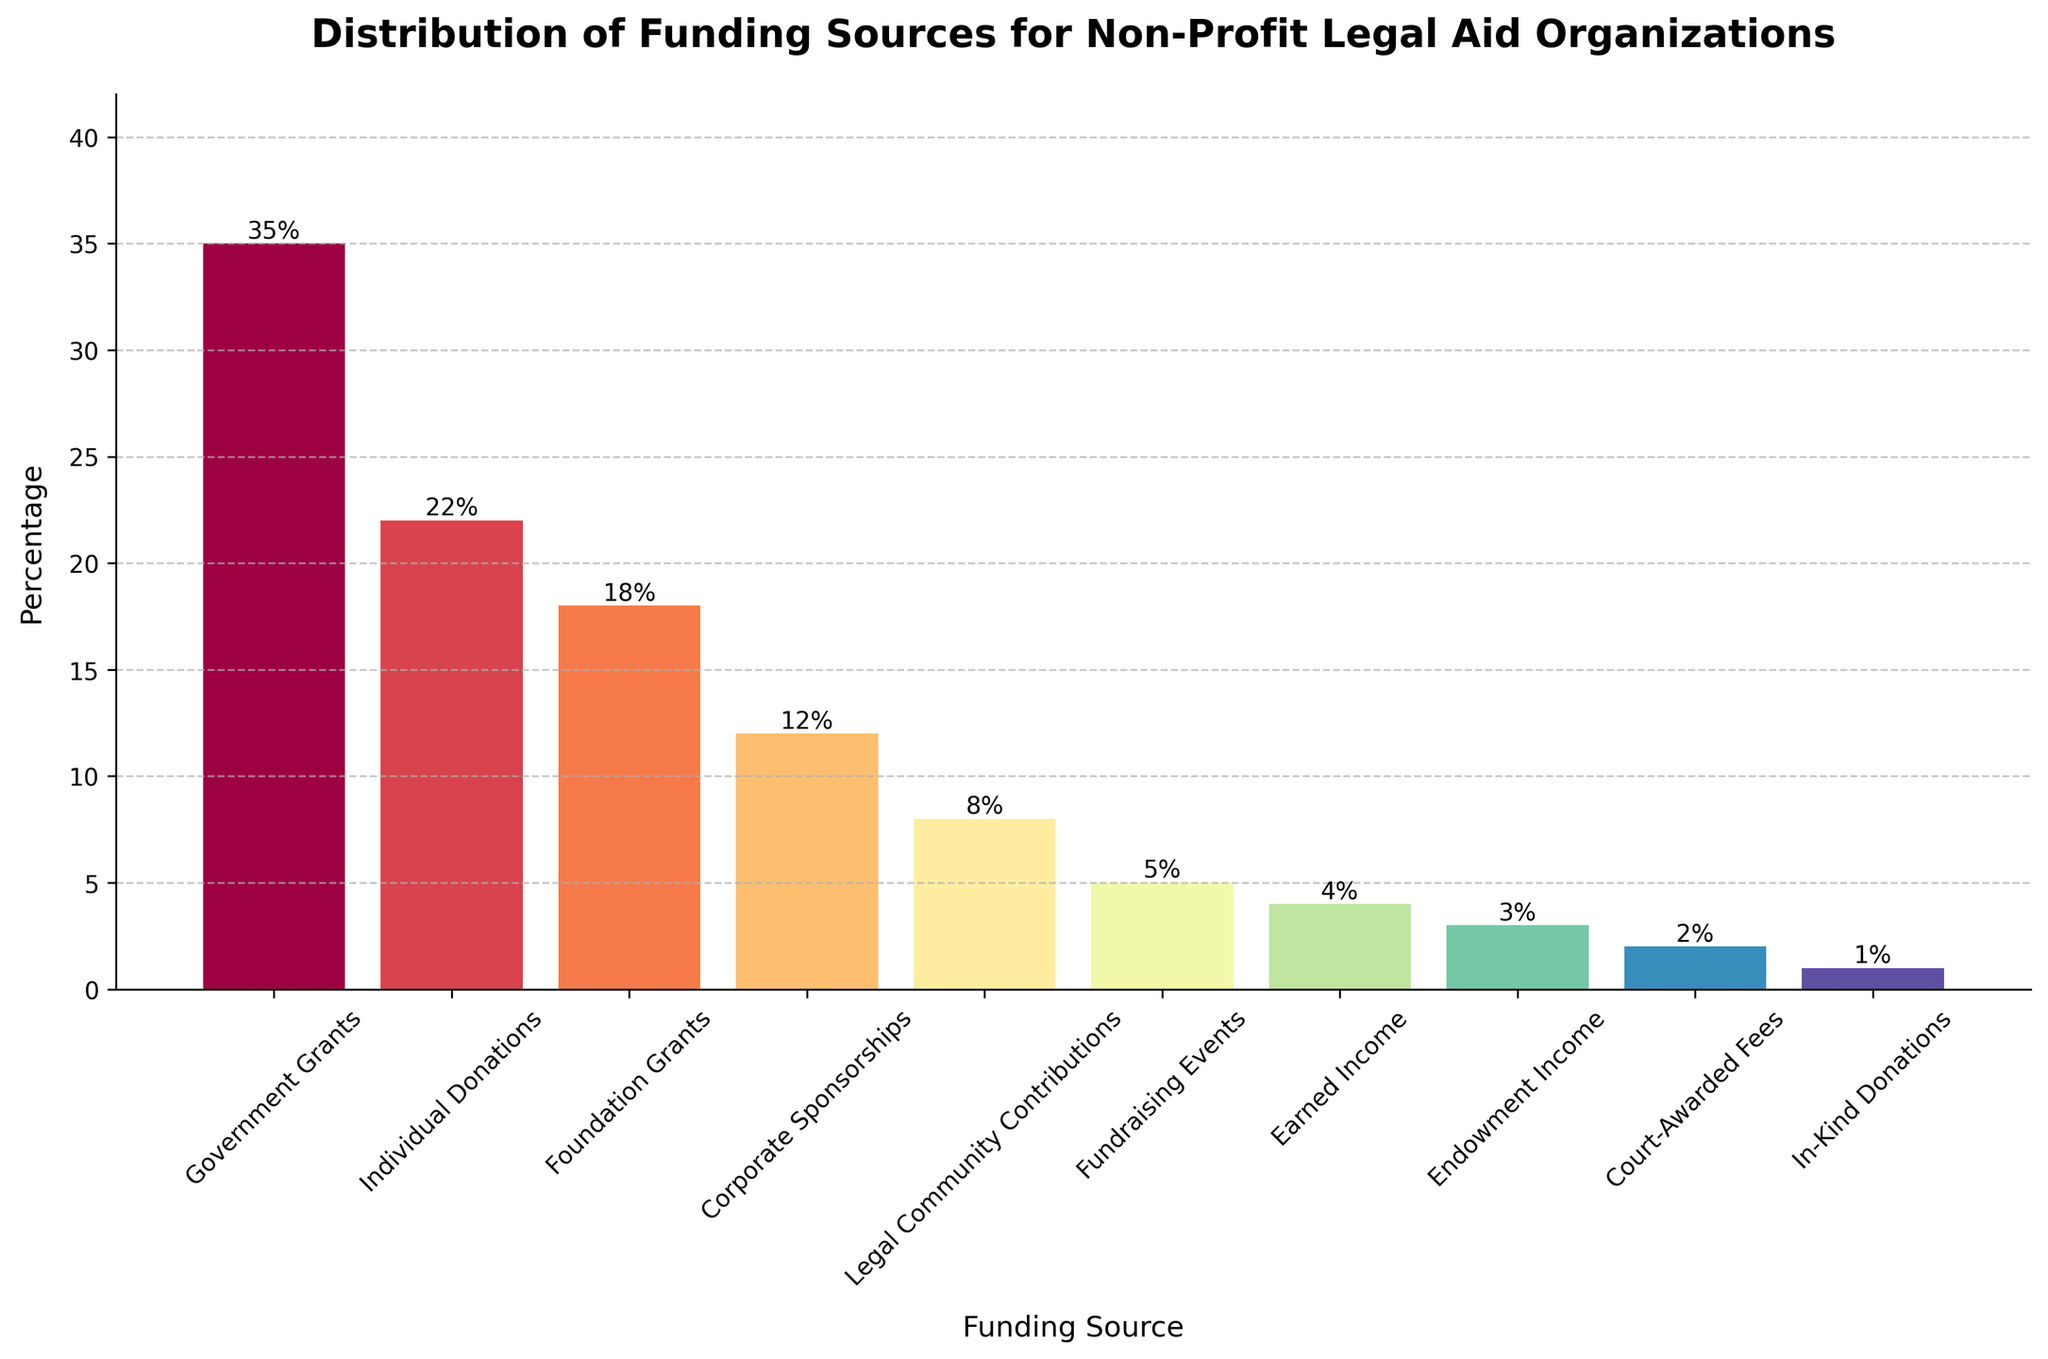Which funding source has the highest percentage of contributions? By looking at the heights of the bars, the highest one corresponds to "Government Grants".
Answer: Government Grants Which funding source provides less than 5% of the total funding? Any bar that is lower than 5% in height corresponds to those funding sources. They are: Earned Income, Endowment Income, Court-Awarded Fees, and In-Kind Donations.
Answer: Earned Income, Endowment Income, Court-Awarded Fees, In-Kind Donations How much more funding do Individual Donations contribute compared to Corporate Sponsorships? The bar for Individual Donations is at 22%, and the bar for Corporate Sponsorships is at 12%. The difference is calculated as 22% - 12% = 10%.
Answer: 10% Which funding sources combined contribute exactly 23% of the total funding? Adding up the percentages, Legal Community Contributions (8%) + Fundraising Events (5%) + Earned Income (4%) + Endowment Income (3%) + Court-Awarded Fees (2%) + In-Kind Donations (1%) = 23%.
Answer: Legal Community Contributions, Fundraising Events, Earned Income, Endowment Income, Court-Awarded Fees, In-Kind Donations Why is the bar for Government Grants highlighted visually? The Government Grants bar is the tallest, indicating it has the highest percentage of contributions.
Answer: It represents the highest percentage Which funding source has a percentage closest to the average percentage of all funding sources? First, calculate the average: The sum of all percentages is 110%. There are 10 funding sources, so the average is 110% / 10 = 11%. The Funding Source closest to 11% is Corporate Sponsorships at 12%.
Answer: Corporate Sponsorships What is the combined percentage of contributions from Foundation Grants and Legal Community Contributions? The bar for Foundation Grants is at 18%, and Legal Community Contributions is at 8%. Adding them gives 18% + 8% = 26%.
Answer: 26% Which sources provide more than 15% of the total funding? Any bar higher than 15% in height corresponds to those funding sources. They are: Government Grants and Individual Donations.
Answer: Government Grants, Individual Donations 